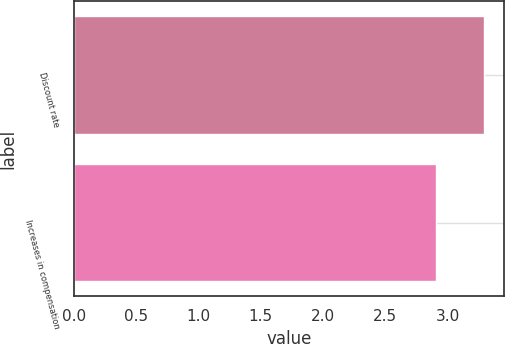Convert chart. <chart><loc_0><loc_0><loc_500><loc_500><bar_chart><fcel>Discount rate<fcel>Increases in compensation<nl><fcel>3.29<fcel>2.91<nl></chart> 